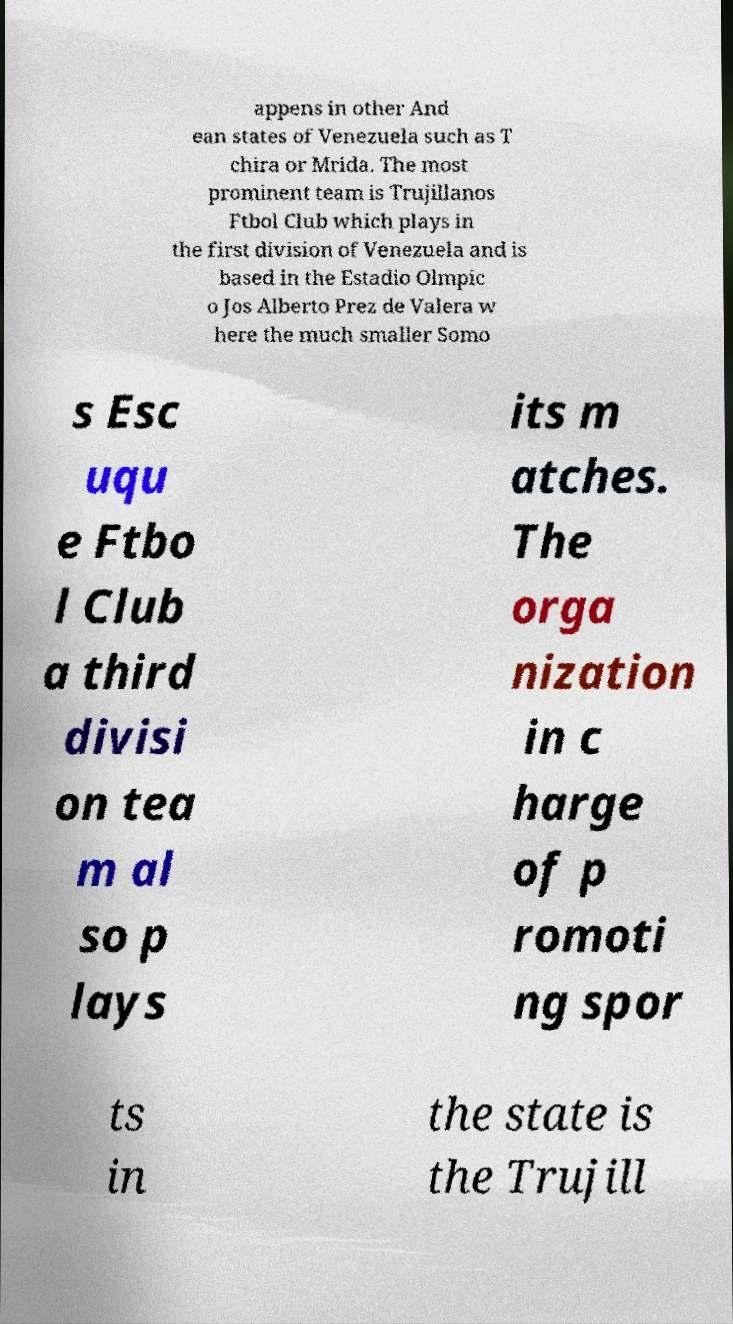Can you read and provide the text displayed in the image?This photo seems to have some interesting text. Can you extract and type it out for me? appens in other And ean states of Venezuela such as T chira or Mrida. The most prominent team is Trujillanos Ftbol Club which plays in the first division of Venezuela and is based in the Estadio Olmpic o Jos Alberto Prez de Valera w here the much smaller Somo s Esc uqu e Ftbo l Club a third divisi on tea m al so p lays its m atches. The orga nization in c harge of p romoti ng spor ts in the state is the Trujill 